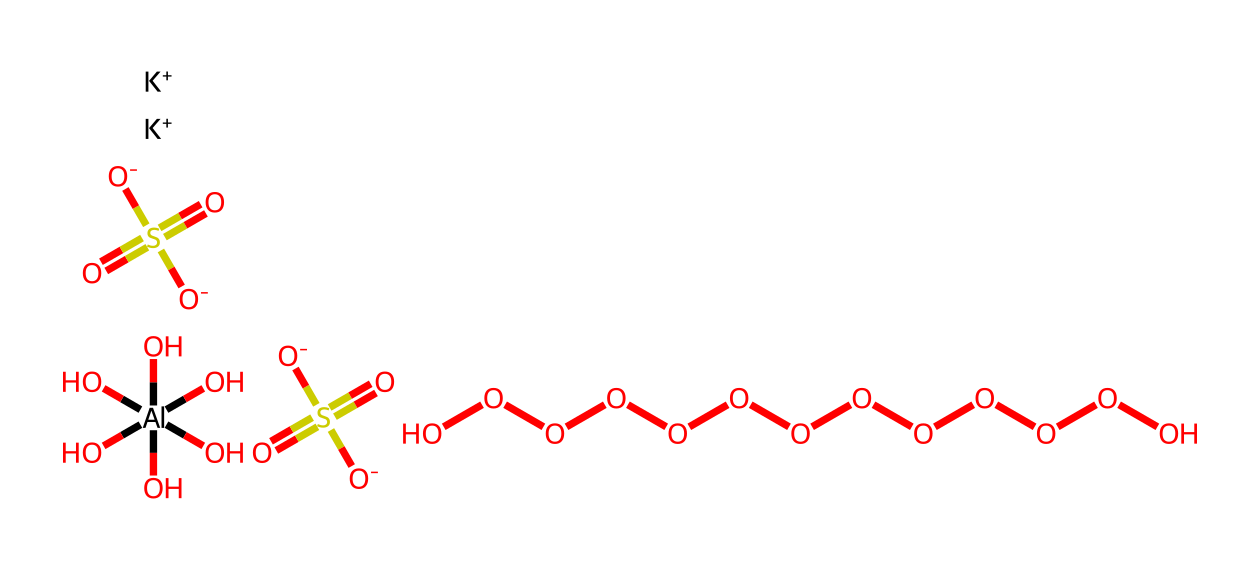What is the central metal atom in potassium alum? The structure contains aluminum atoms, indicated by the [Al] in the SMILES representation. It serves as the central metal in the coordination compound.
Answer: aluminum How many sulfate groups are present in this compound? The SMILES shows multiple occurrences of the sulfate fragment (O=S(=O)([O-])[O-]), and by counting, we see there are two of these sulfate groups.
Answer: two What is the oxidation state of aluminum in potassium alum? In coordination compounds like this one, aluminum generally has an oxidation state of +3, as it is usually found in the +3 oxidation state in such compounds.
Answer: +3 How many potassium ions are present in the structure? The representation includes two [K+] ions explicitly mentioned, indicating that there are two potassium ions in the compound.
Answer: two What role does potassium alum play in traditional water purification? Potassium alum acts as a coagulant, which helps in aggregating suspended particles in water so they can be easily removed.
Answer: coagulant Which type of bonding can be found in coordination compounds like potassium alum? The compound displays coordination bonding between the aluminum atom and the surrounding sulfate and hydroxide ions. Coordination bonds are characterized by the attachment of ligands to a central metal atom.
Answer: coordination bonding 